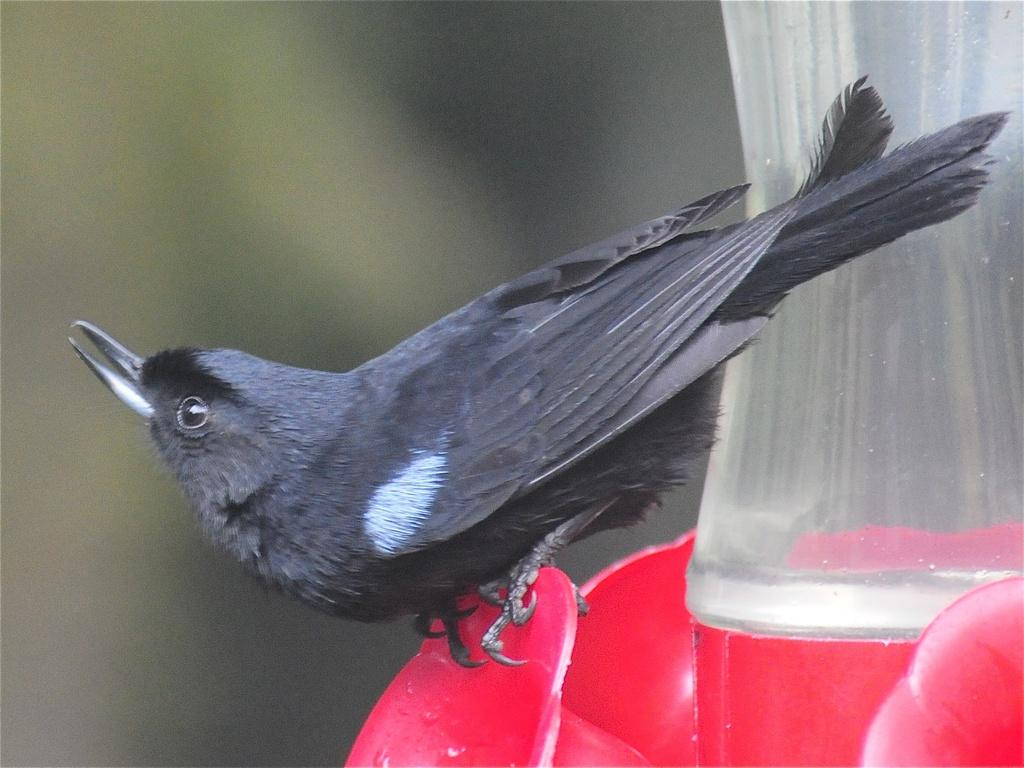What type of animal can be seen in the image? There is a bird in the image. What color is the bird? The bird is black in color. What other object is present in the image? There is an object in the image, and it is red in color. Can you describe the background of the image? The background of the image is blurred. What is the purpose of the light in the image? There is no light present in the image; it only features a black bird, a red object, and a blurred background. 